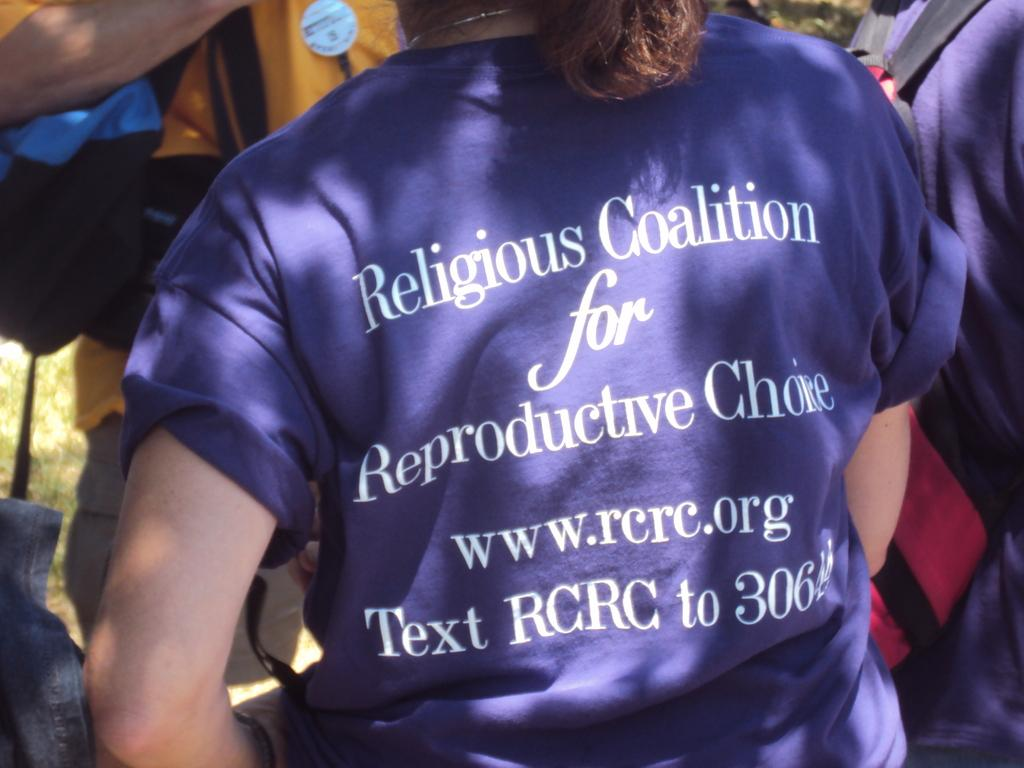<image>
Describe the image concisely. Person wearing a shirt that starts off by saying Religious Coalition. 